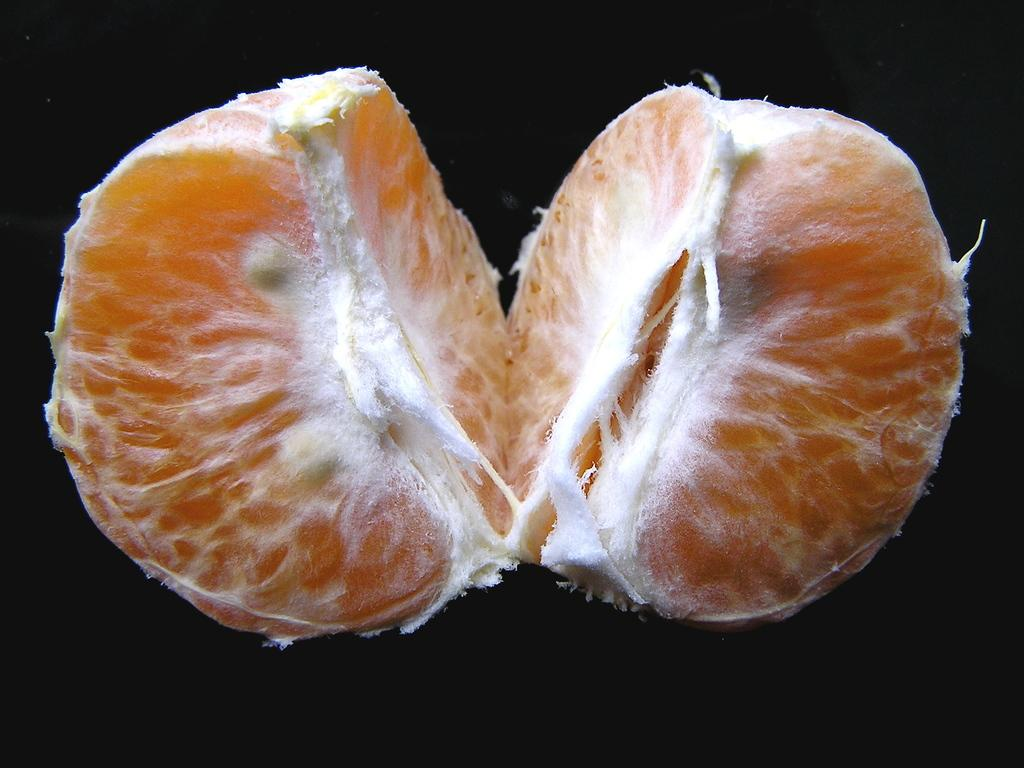What objects are present in the image? There are two orange pieces in the image. What can be observed about the background of the image? The background of the image is dark. What type of engine is visible in the image? There is no engine present in the image; it features two orange pieces. Is there a spy observing the orange pieces in the image? There is no indication of a spy or any person in the image, which only contains two orange pieces and a dark background. 